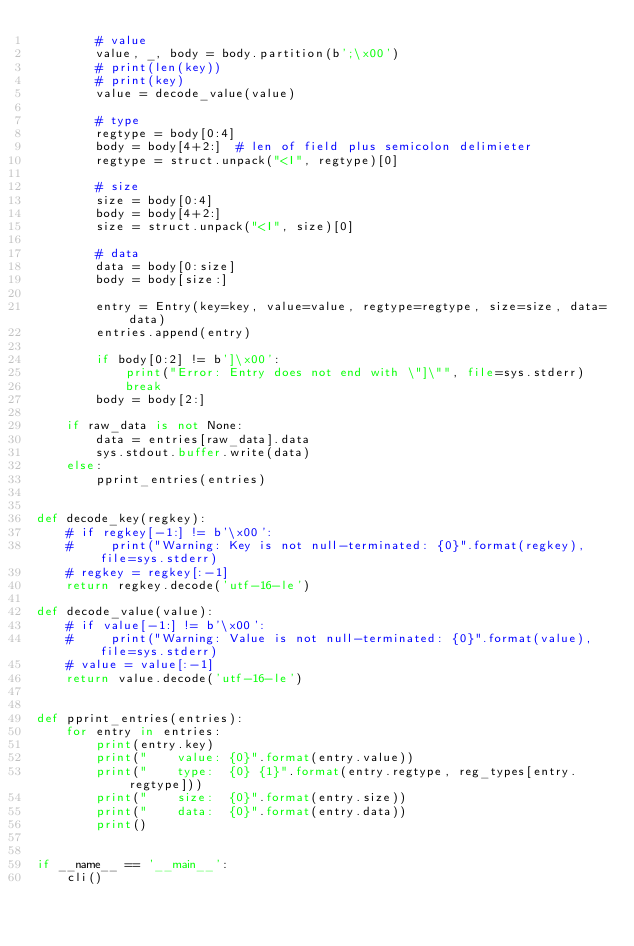<code> <loc_0><loc_0><loc_500><loc_500><_Python_>        # value
        value, _, body = body.partition(b';\x00')
        # print(len(key))
        # print(key)
        value = decode_value(value)

        # type
        regtype = body[0:4]
        body = body[4+2:]  # len of field plus semicolon delimieter
        regtype = struct.unpack("<I", regtype)[0]

        # size
        size = body[0:4]
        body = body[4+2:]
        size = struct.unpack("<I", size)[0]

        # data
        data = body[0:size]
        body = body[size:]

        entry = Entry(key=key, value=value, regtype=regtype, size=size, data=data)
        entries.append(entry)

        if body[0:2] != b']\x00':
            print("Error: Entry does not end with \"]\"", file=sys.stderr)
            break
        body = body[2:]

    if raw_data is not None:
        data = entries[raw_data].data
        sys.stdout.buffer.write(data)
    else:
        pprint_entries(entries)


def decode_key(regkey):
    # if regkey[-1:] != b'\x00':
    #     print("Warning: Key is not null-terminated: {0}".format(regkey), file=sys.stderr)
    # regkey = regkey[:-1]
    return regkey.decode('utf-16-le')

def decode_value(value):
    # if value[-1:] != b'\x00':
    #     print("Warning: Value is not null-terminated: {0}".format(value), file=sys.stderr)
    # value = value[:-1]
    return value.decode('utf-16-le')


def pprint_entries(entries):
    for entry in entries:
        print(entry.key)
        print("    value: {0}".format(entry.value))
        print("    type:  {0} {1}".format(entry.regtype, reg_types[entry.regtype]))
        print("    size:  {0}".format(entry.size))
        print("    data:  {0}".format(entry.data))
        print()


if __name__ == '__main__':
    cli()
</code> 